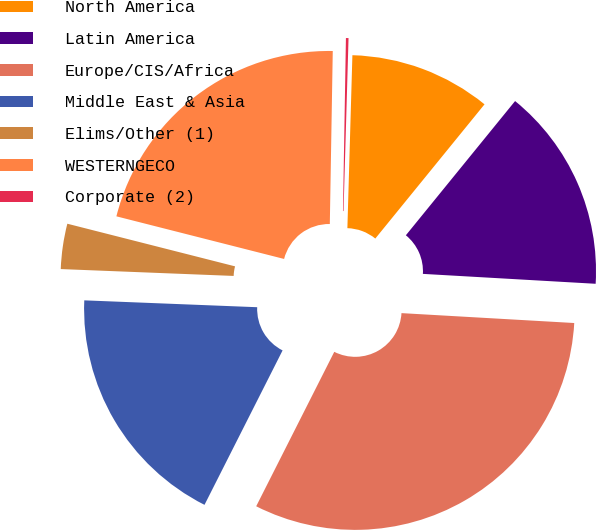<chart> <loc_0><loc_0><loc_500><loc_500><pie_chart><fcel>North America<fcel>Latin America<fcel>Europe/CIS/Africa<fcel>Middle East & Asia<fcel>Elims/Other (1)<fcel>WESTERNGECO<fcel>Corporate (2)<nl><fcel>10.41%<fcel>15.04%<fcel>31.54%<fcel>18.18%<fcel>3.33%<fcel>21.31%<fcel>0.19%<nl></chart> 